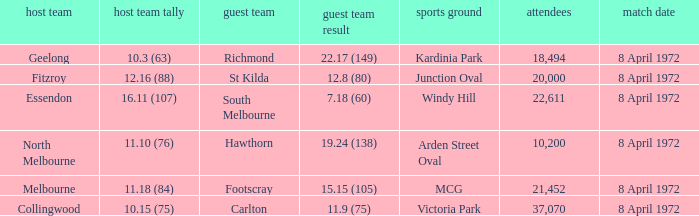Which Home team score has a Home team of geelong? 10.3 (63). 